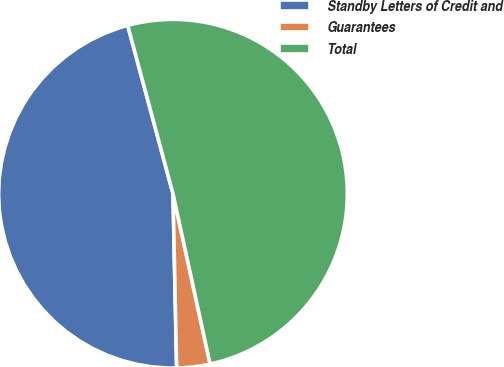<chart> <loc_0><loc_0><loc_500><loc_500><pie_chart><fcel>Standby Letters of Credit and<fcel>Guarantees<fcel>Total<nl><fcel>46.15%<fcel>3.08%<fcel>50.77%<nl></chart> 